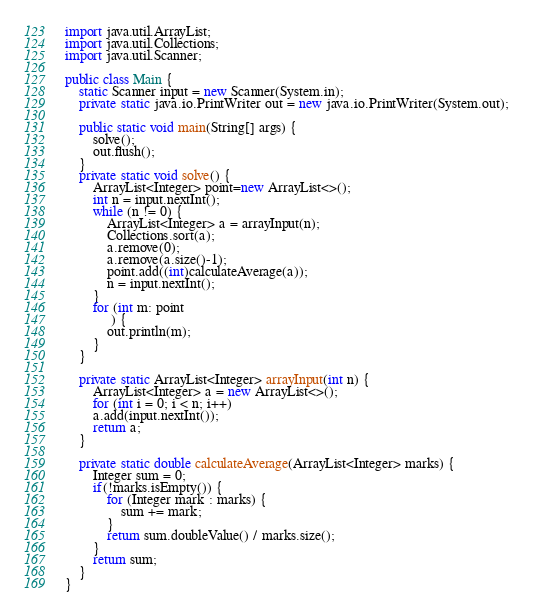Convert code to text. <code><loc_0><loc_0><loc_500><loc_500><_Java_>import java.util.ArrayList;
import java.util.Collections;
import java.util.Scanner;

public class Main {
    static Scanner input = new Scanner(System.in);
    private static java.io.PrintWriter out = new java.io.PrintWriter(System.out);   

    public static void main(String[] args) {
        solve();
        out.flush();
    }    
    private static void solve() {
        ArrayList<Integer> point=new ArrayList<>();
        int n = input.nextInt();
        while (n != 0) {
            ArrayList<Integer> a = arrayInput(n);
            Collections.sort(a);
            a.remove(0);
            a.remove(a.size()-1);
            point.add((int)calculateAverage(a));
            n = input.nextInt();
        }
        for (int m: point
             ) {
            out.println(m);
        }
    }    

    private static ArrayList<Integer> arrayInput(int n) {
        ArrayList<Integer> a = new ArrayList<>();
        for (int i = 0; i < n; i++)
        a.add(input.nextInt());
        return a;
    }

    private static double calculateAverage(ArrayList<Integer> marks) {
        Integer sum = 0;
        if(!marks.isEmpty()) {
            for (Integer mark : marks) {
                sum += mark;
            }
            return sum.doubleValue() / marks.size();
        }
        return sum;
    }
}
</code> 